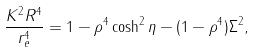Convert formula to latex. <formula><loc_0><loc_0><loc_500><loc_500>\frac { K ^ { 2 } R ^ { 4 } } { r _ { e } ^ { 4 } } = 1 - \rho ^ { 4 } \cosh ^ { 2 } \eta - ( 1 - \rho ^ { 4 } ) \Sigma ^ { 2 } ,</formula> 